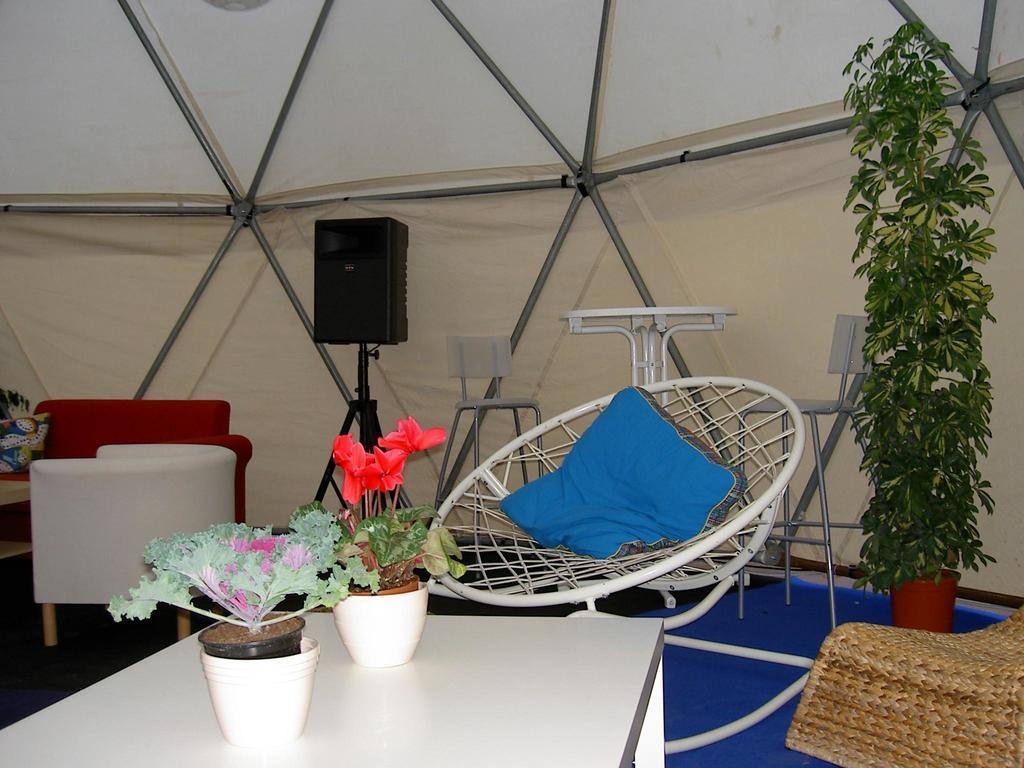In one or two sentences, can you explain what this image depicts? Here we can see couple of chairs placed and here there is a couch and at the front there is a table on which there are flower plants and at the back side we can see a speaker held on a stand and at the right side we can see a plant 